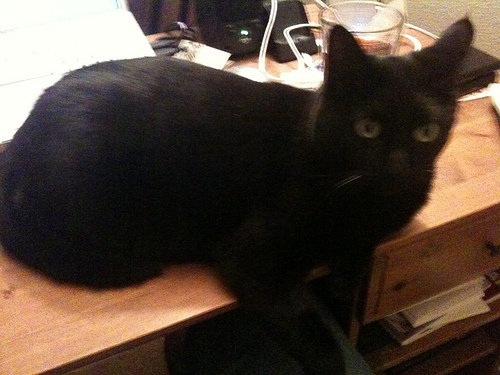Describe the objects in this image and their specific colors. I can see cat in white, black, and gray tones, laptop in white, gray, darkgray, and lightgray tones, book in ivory, gray, black, brown, and maroon tones, cup in white, ivory, tan, and gray tones, and book in white, black, maroon, and brown tones in this image. 